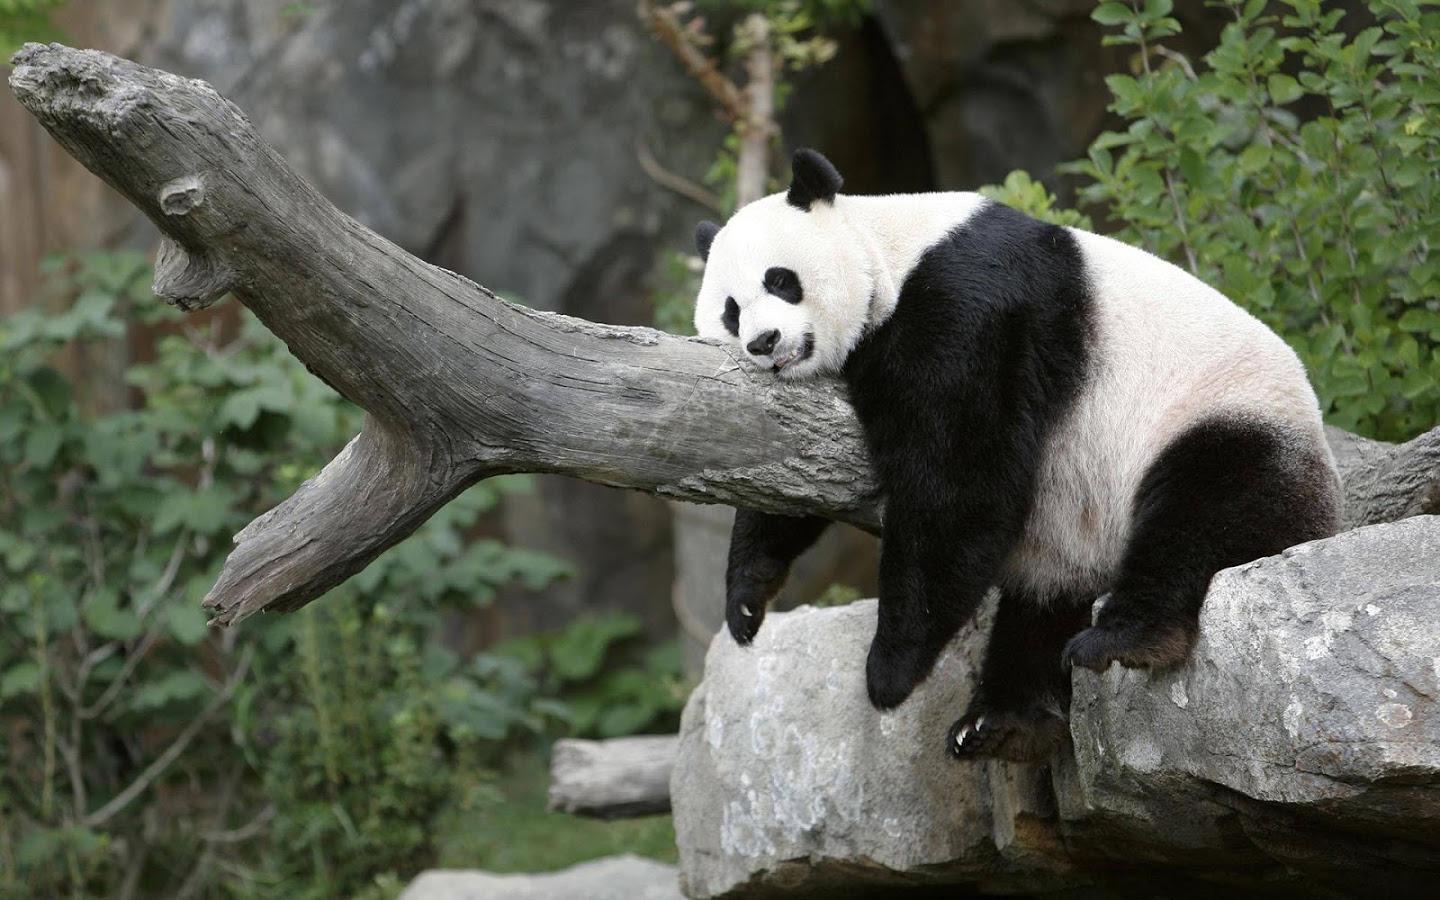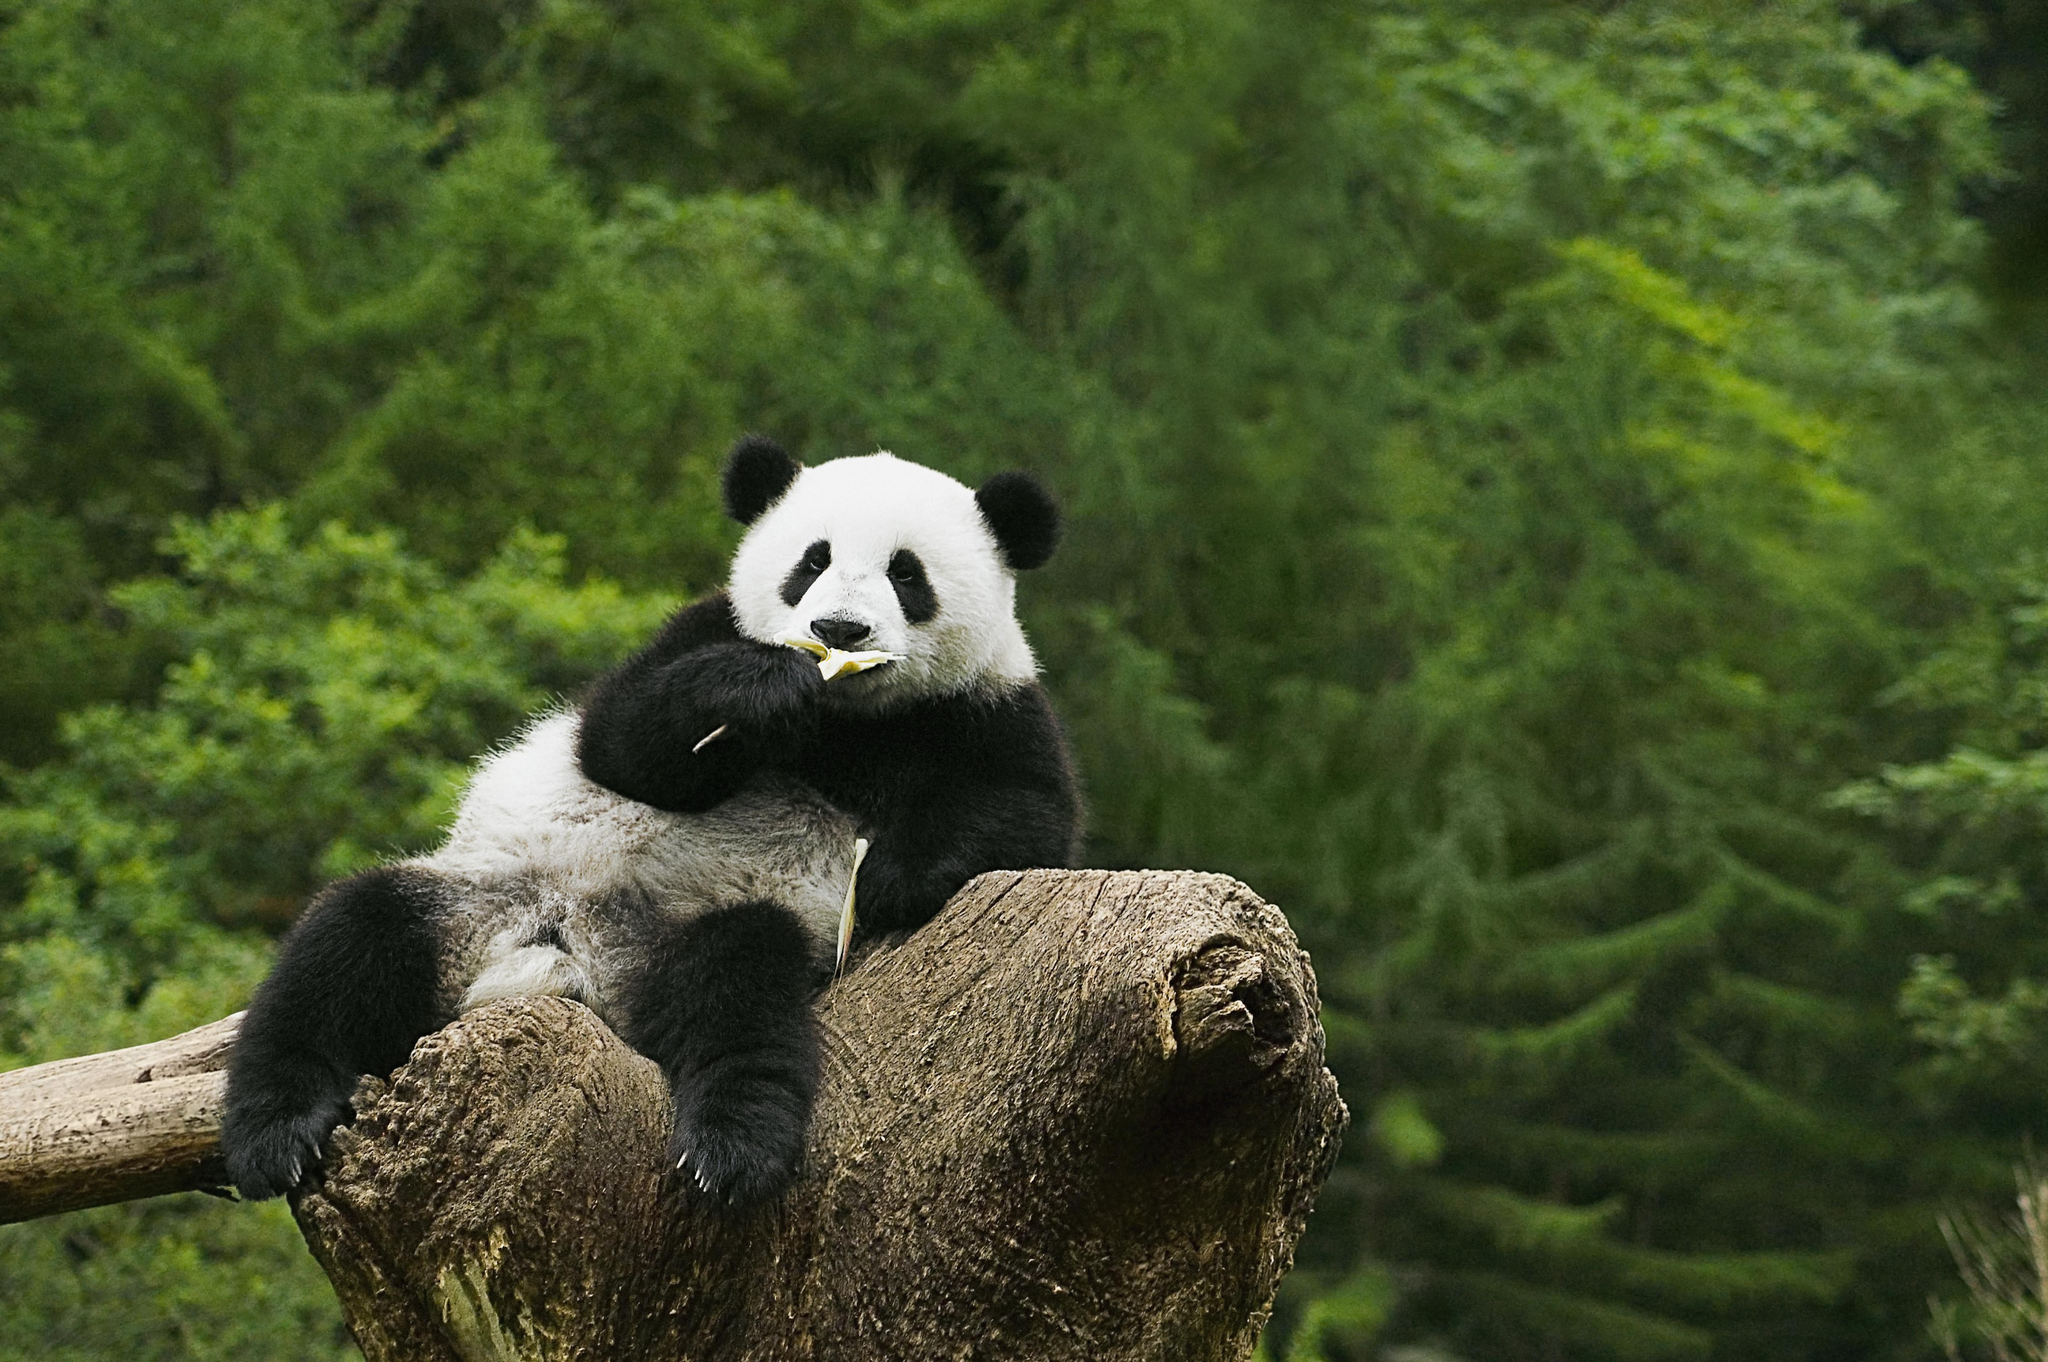The first image is the image on the left, the second image is the image on the right. Considering the images on both sides, is "Two pandas are laying forward." valid? Answer yes or no. No. 